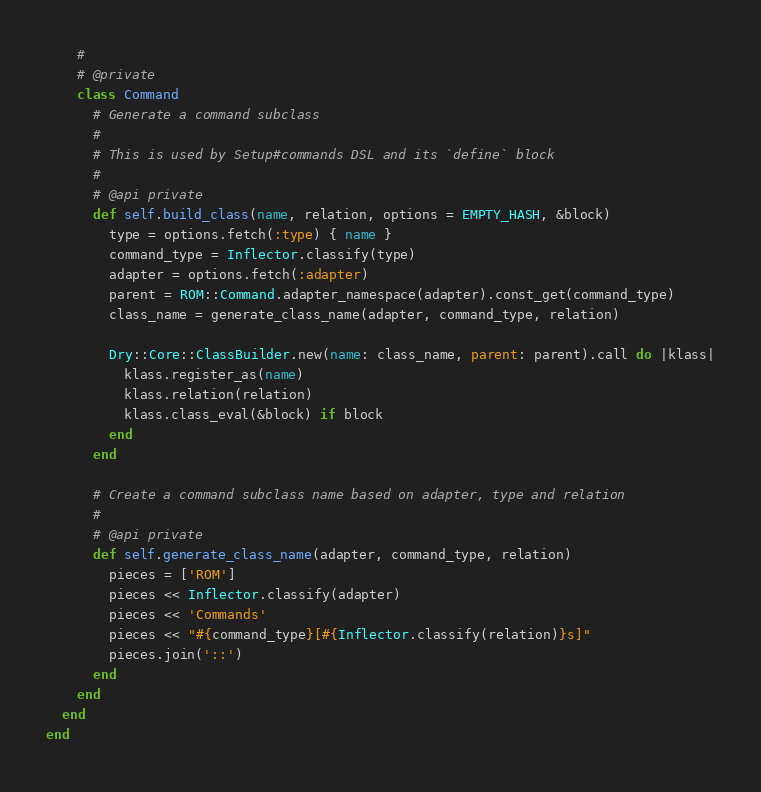Convert code to text. <code><loc_0><loc_0><loc_500><loc_500><_Ruby_>    #
    # @private
    class Command
      # Generate a command subclass
      #
      # This is used by Setup#commands DSL and its `define` block
      #
      # @api private
      def self.build_class(name, relation, options = EMPTY_HASH, &block)
        type = options.fetch(:type) { name }
        command_type = Inflector.classify(type)
        adapter = options.fetch(:adapter)
        parent = ROM::Command.adapter_namespace(adapter).const_get(command_type)
        class_name = generate_class_name(adapter, command_type, relation)

        Dry::Core::ClassBuilder.new(name: class_name, parent: parent).call do |klass|
          klass.register_as(name)
          klass.relation(relation)
          klass.class_eval(&block) if block
        end
      end

      # Create a command subclass name based on adapter, type and relation
      #
      # @api private
      def self.generate_class_name(adapter, command_type, relation)
        pieces = ['ROM']
        pieces << Inflector.classify(adapter)
        pieces << 'Commands'
        pieces << "#{command_type}[#{Inflector.classify(relation)}s]"
        pieces.join('::')
      end
    end
  end
end
</code> 